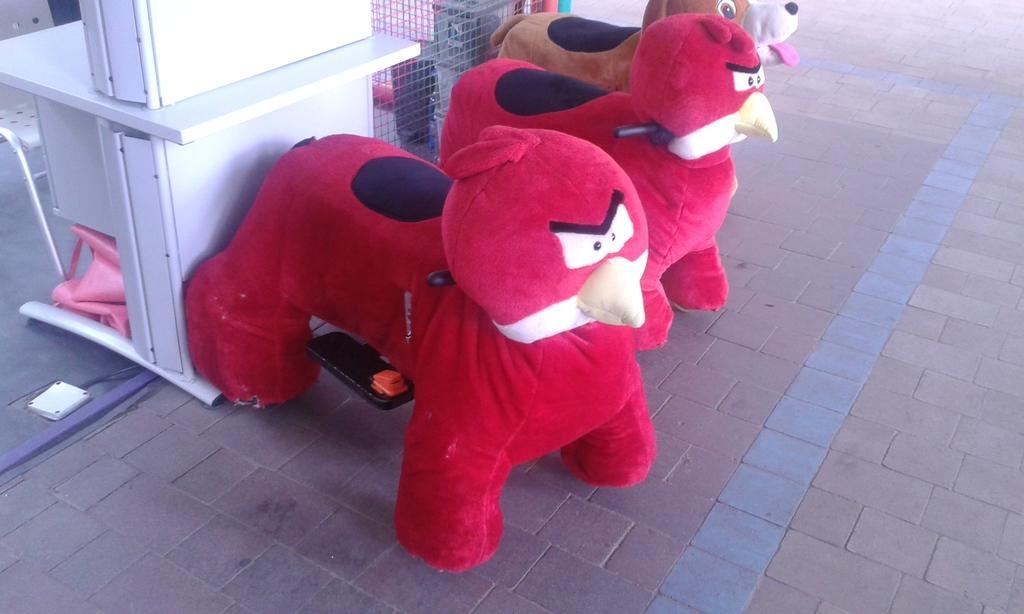How would you summarize this image in a sentence or two? In this image we can see toys and pavement. On the right side of the image, we can see a white color object. At the top of the image, we can see the mesh. Behind the mesh, there are some objects. We can see a chair in the top left of the image. 